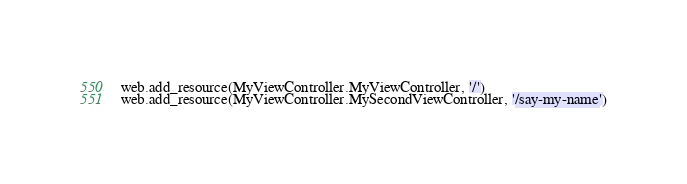Convert code to text. <code><loc_0><loc_0><loc_500><loc_500><_Python_>web.add_resource(MyViewController.MyViewController, '/')
web.add_resource(MyViewController.MySecondViewController, '/say-my-name')</code> 